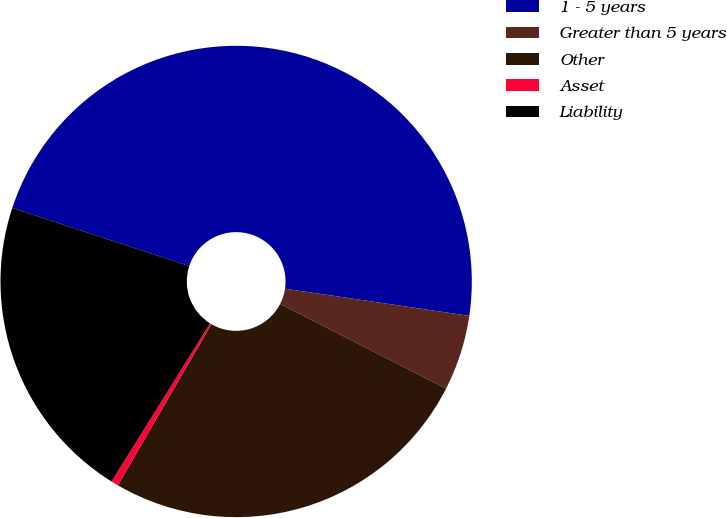Convert chart to OTSL. <chart><loc_0><loc_0><loc_500><loc_500><pie_chart><fcel>1 - 5 years<fcel>Greater than 5 years<fcel>Other<fcel>Asset<fcel>Liability<nl><fcel>47.28%<fcel>5.18%<fcel>25.86%<fcel>0.5%<fcel>21.18%<nl></chart> 